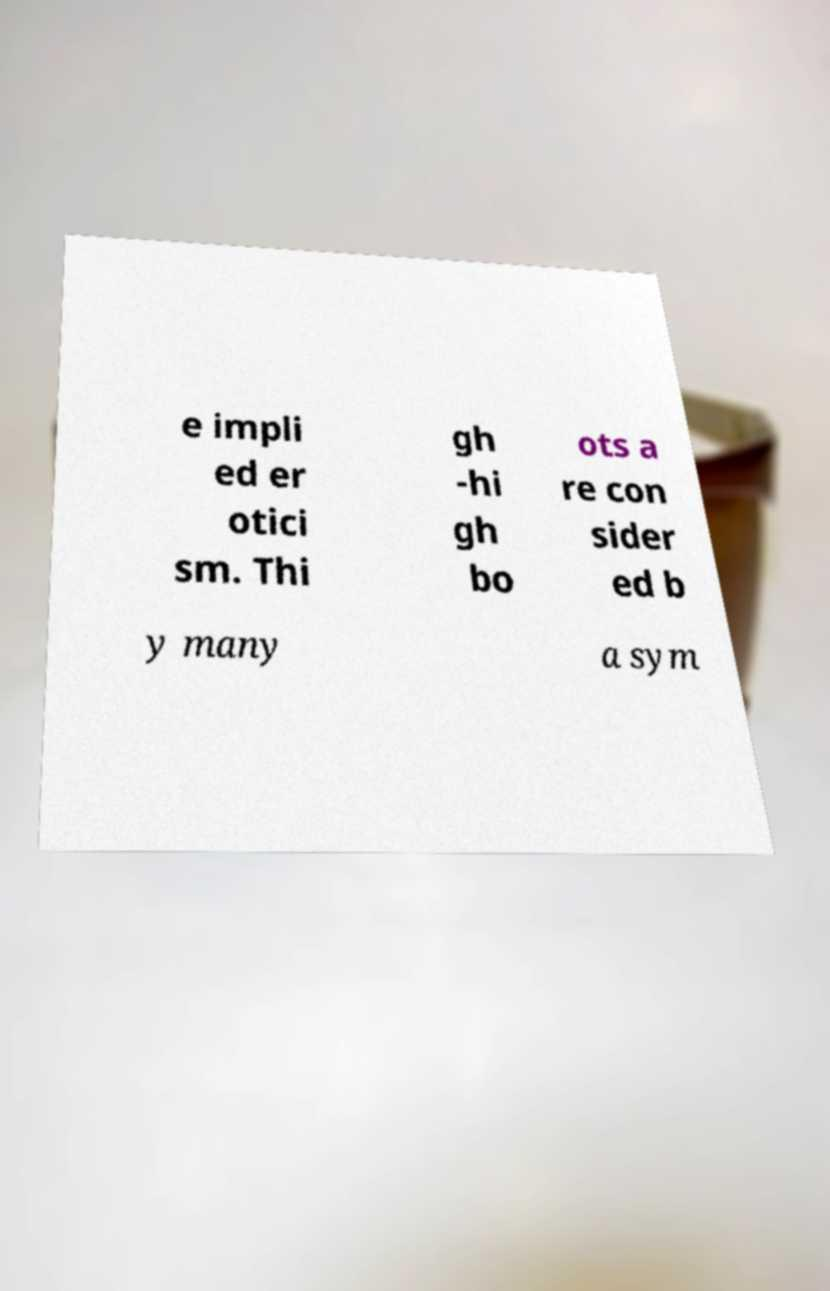Can you read and provide the text displayed in the image?This photo seems to have some interesting text. Can you extract and type it out for me? e impli ed er otici sm. Thi gh -hi gh bo ots a re con sider ed b y many a sym 